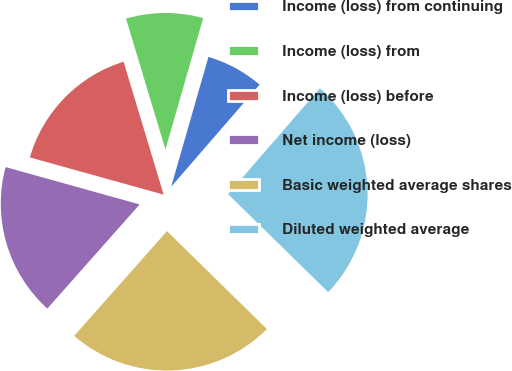Convert chart. <chart><loc_0><loc_0><loc_500><loc_500><pie_chart><fcel>Income (loss) from continuing<fcel>Income (loss) from<fcel>Income (loss) before<fcel>Net income (loss)<fcel>Basic weighted average shares<fcel>Diluted weighted average<nl><fcel>6.91%<fcel>9.11%<fcel>16.02%<fcel>17.78%<fcel>24.21%<fcel>25.97%<nl></chart> 